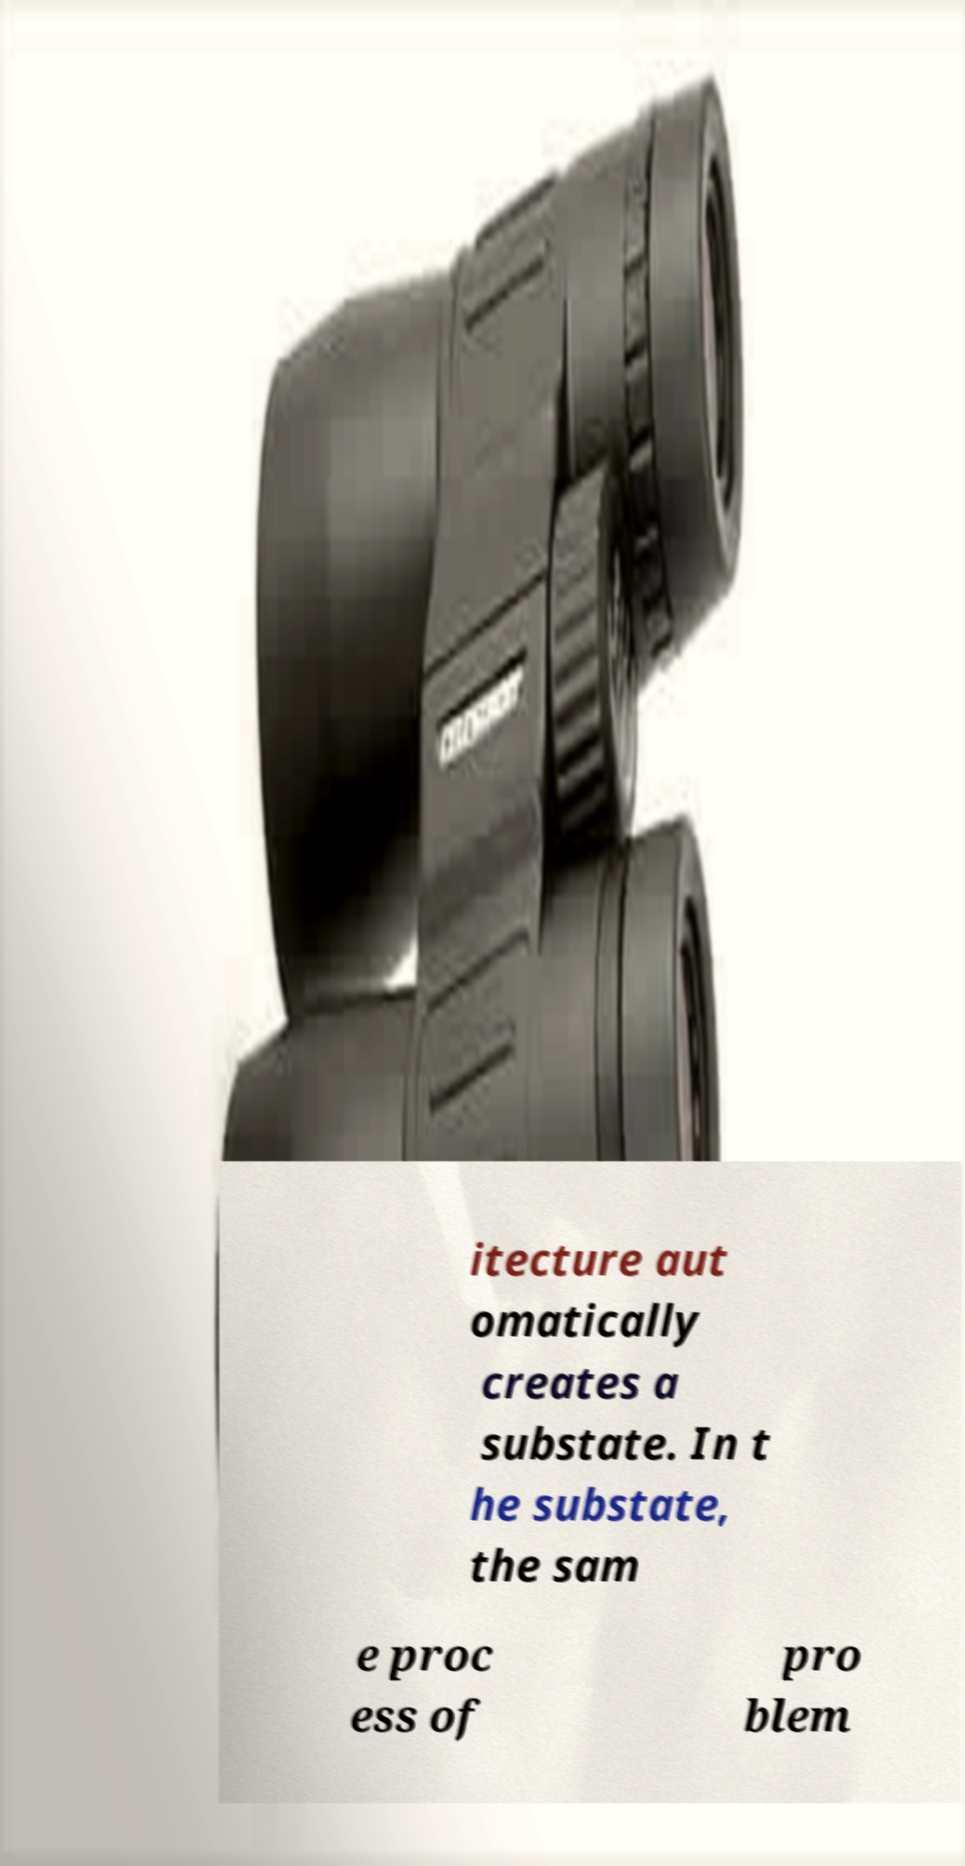Could you extract and type out the text from this image? itecture aut omatically creates a substate. In t he substate, the sam e proc ess of pro blem 